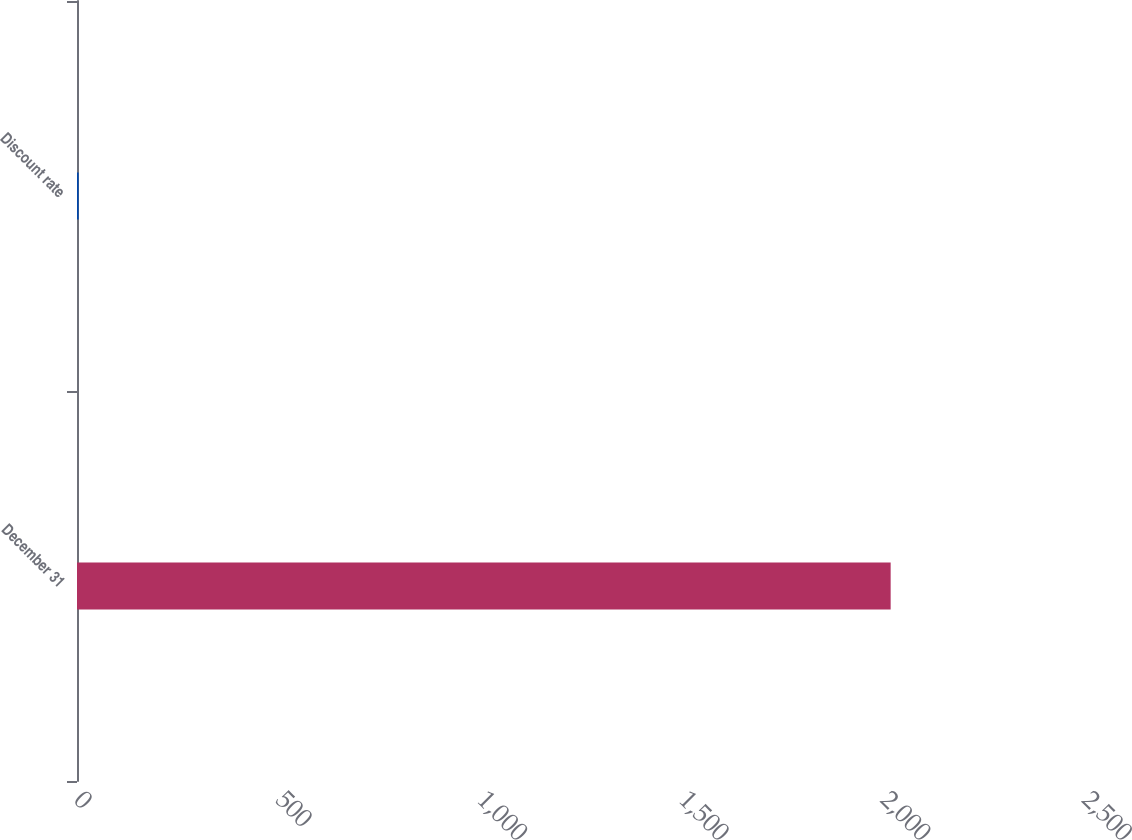Convert chart to OTSL. <chart><loc_0><loc_0><loc_500><loc_500><bar_chart><fcel>December 31<fcel>Discount rate<nl><fcel>2018<fcel>4.1<nl></chart> 